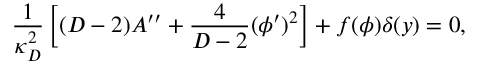<formula> <loc_0><loc_0><loc_500><loc_500>{ \frac { 1 } { \kappa _ { D } ^ { 2 } } } \left [ ( D - 2 ) A ^ { \prime \prime } + { \frac { 4 } { D - 2 } } ( \phi ^ { \prime } ) ^ { 2 } \right ] + f ( \phi ) \delta ( y ) = 0 ,</formula> 